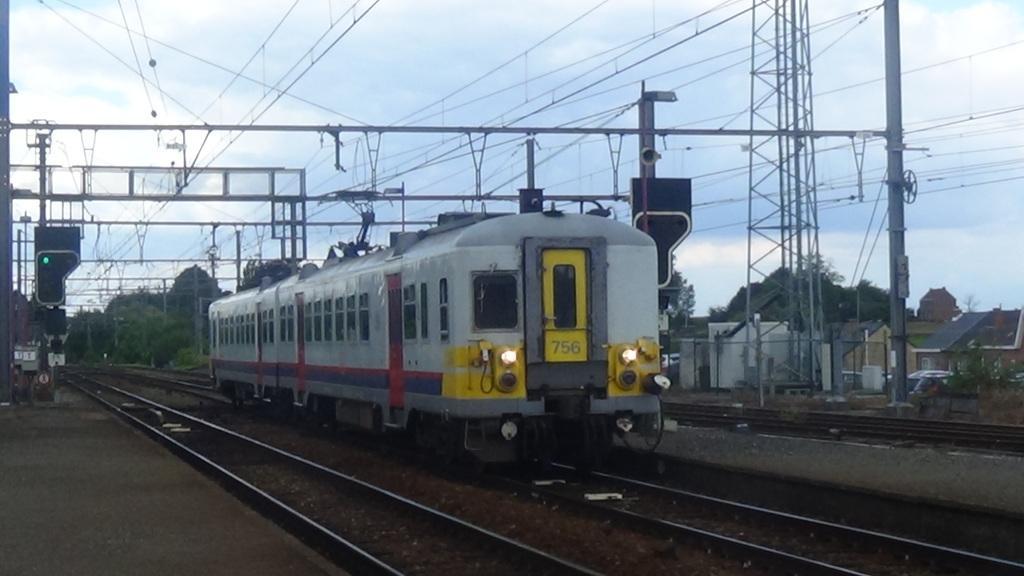Please provide a concise description of this image. In the picture I can see a train is moving on the railway track. Here we can see signal poles, wire, a vehicle, houses, trees on the right side of the image and in the background, we can see the plain sky. 